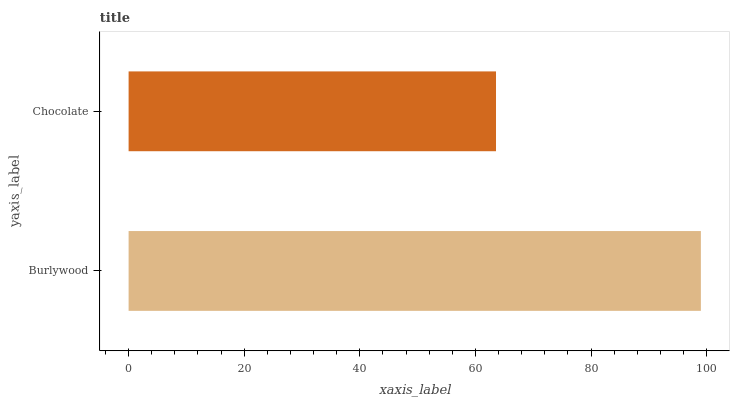Is Chocolate the minimum?
Answer yes or no. Yes. Is Burlywood the maximum?
Answer yes or no. Yes. Is Chocolate the maximum?
Answer yes or no. No. Is Burlywood greater than Chocolate?
Answer yes or no. Yes. Is Chocolate less than Burlywood?
Answer yes or no. Yes. Is Chocolate greater than Burlywood?
Answer yes or no. No. Is Burlywood less than Chocolate?
Answer yes or no. No. Is Burlywood the high median?
Answer yes or no. Yes. Is Chocolate the low median?
Answer yes or no. Yes. Is Chocolate the high median?
Answer yes or no. No. Is Burlywood the low median?
Answer yes or no. No. 